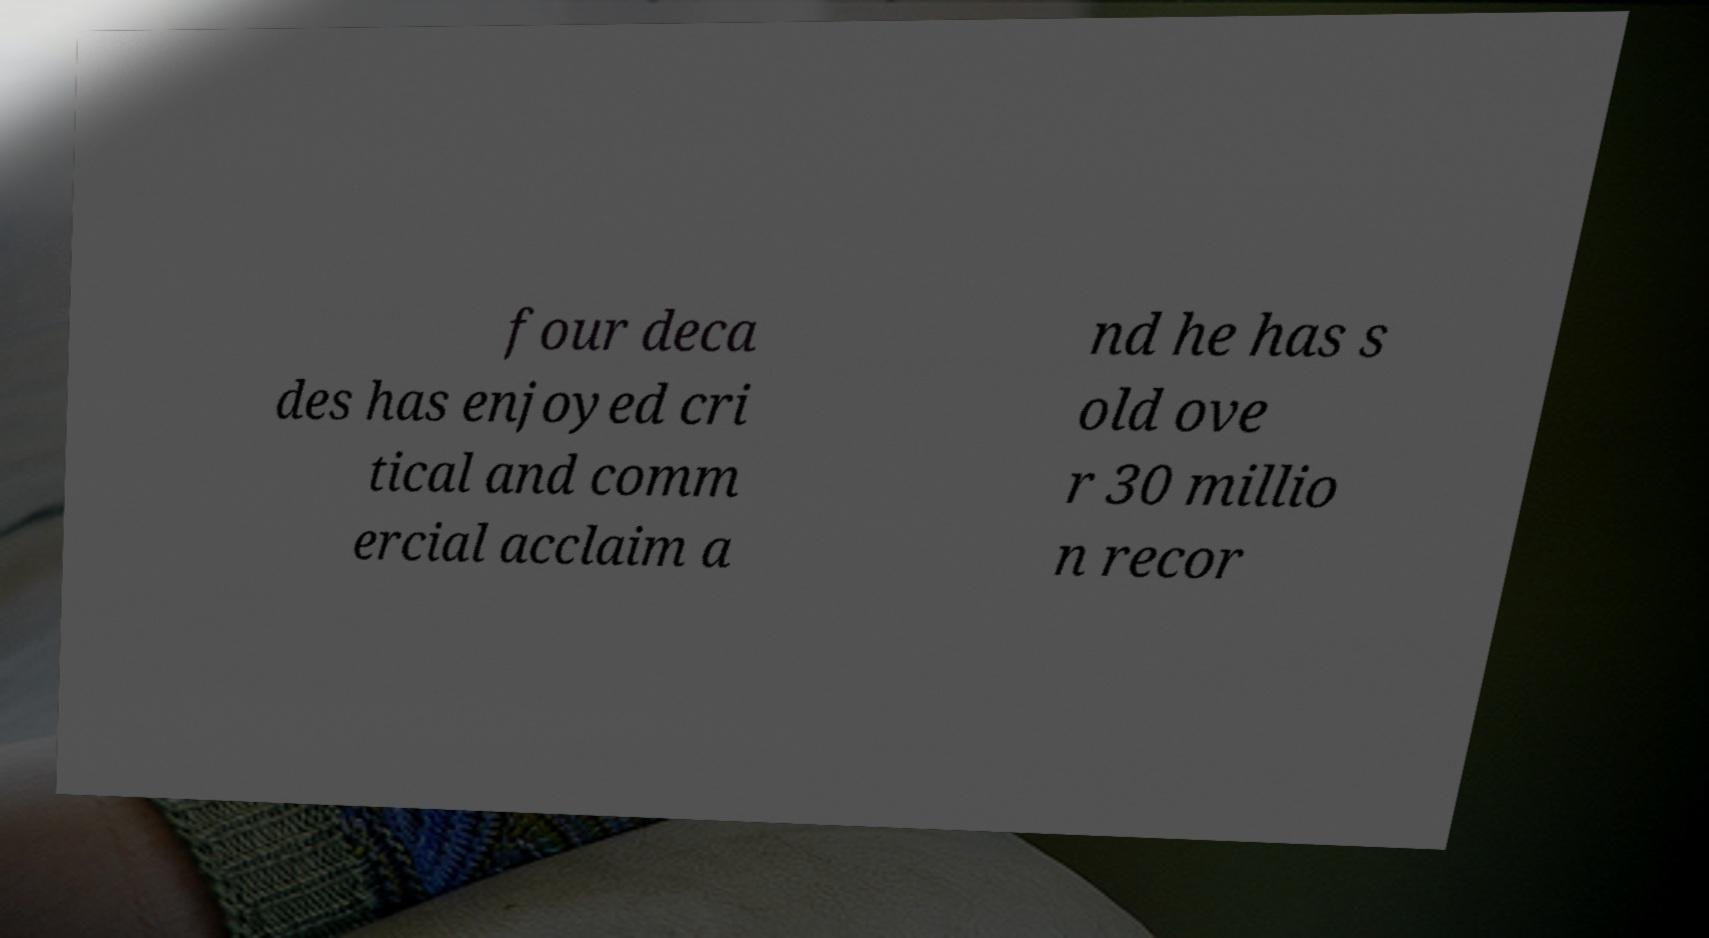Could you assist in decoding the text presented in this image and type it out clearly? four deca des has enjoyed cri tical and comm ercial acclaim a nd he has s old ove r 30 millio n recor 